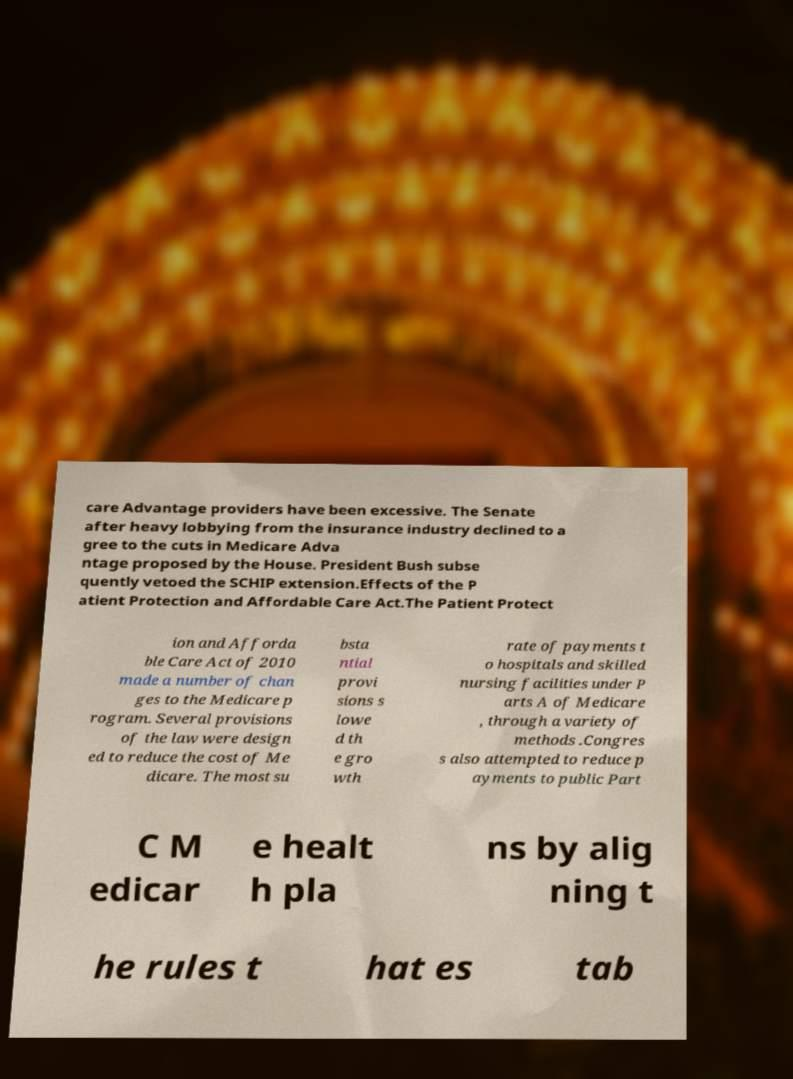Can you read and provide the text displayed in the image?This photo seems to have some interesting text. Can you extract and type it out for me? care Advantage providers have been excessive. The Senate after heavy lobbying from the insurance industry declined to a gree to the cuts in Medicare Adva ntage proposed by the House. President Bush subse quently vetoed the SCHIP extension.Effects of the P atient Protection and Affordable Care Act.The Patient Protect ion and Afforda ble Care Act of 2010 made a number of chan ges to the Medicare p rogram. Several provisions of the law were design ed to reduce the cost of Me dicare. The most su bsta ntial provi sions s lowe d th e gro wth rate of payments t o hospitals and skilled nursing facilities under P arts A of Medicare , through a variety of methods .Congres s also attempted to reduce p ayments to public Part C M edicar e healt h pla ns by alig ning t he rules t hat es tab 